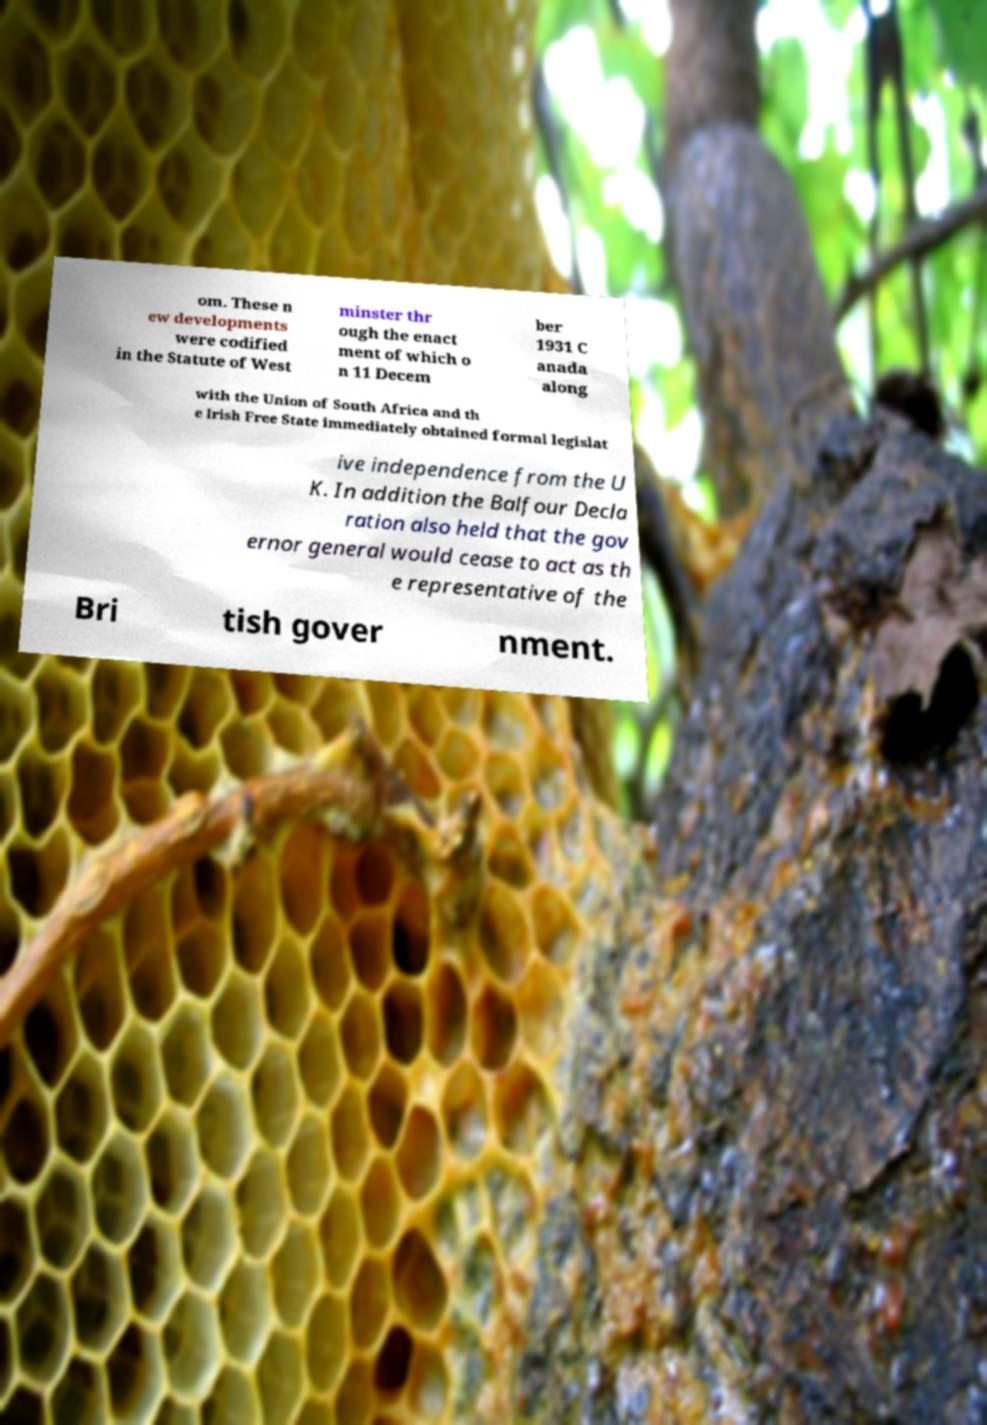What messages or text are displayed in this image? I need them in a readable, typed format. om. These n ew developments were codified in the Statute of West minster thr ough the enact ment of which o n 11 Decem ber 1931 C anada along with the Union of South Africa and th e Irish Free State immediately obtained formal legislat ive independence from the U K. In addition the Balfour Decla ration also held that the gov ernor general would cease to act as th e representative of the Bri tish gover nment. 